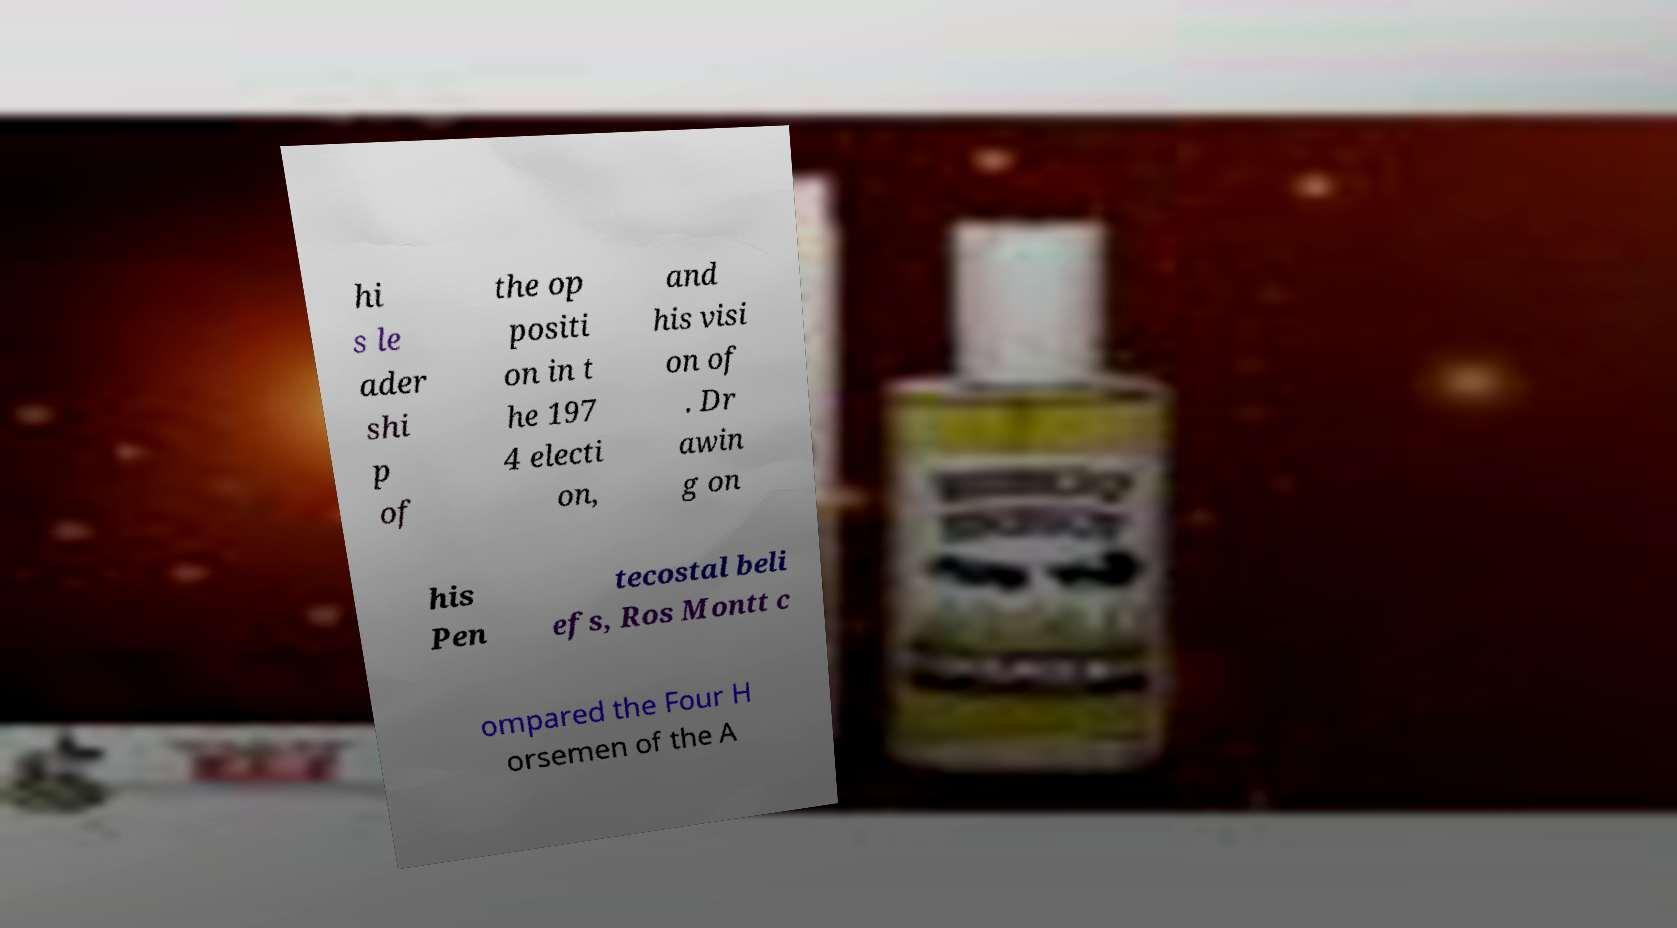Could you extract and type out the text from this image? hi s le ader shi p of the op positi on in t he 197 4 electi on, and his visi on of . Dr awin g on his Pen tecostal beli efs, Ros Montt c ompared the Four H orsemen of the A 